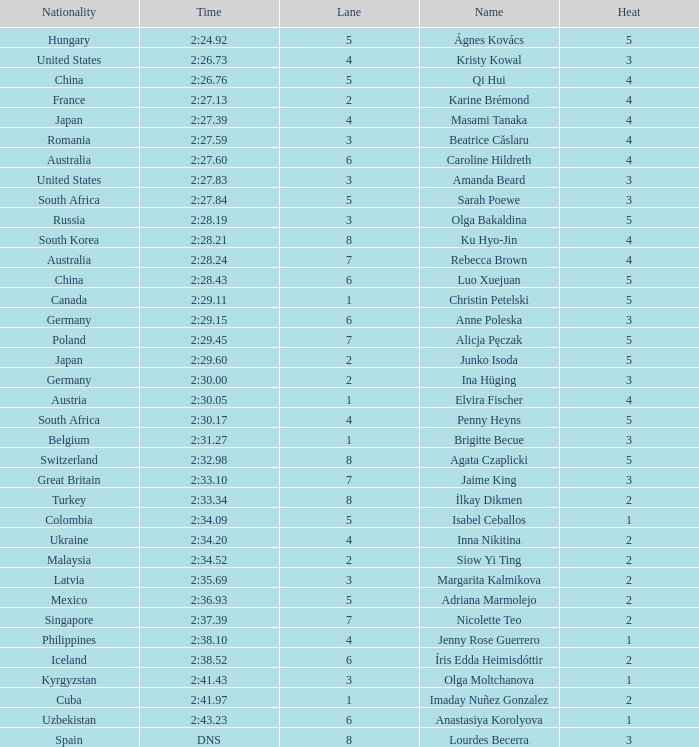What lane did inna nikitina have? 4.0. 